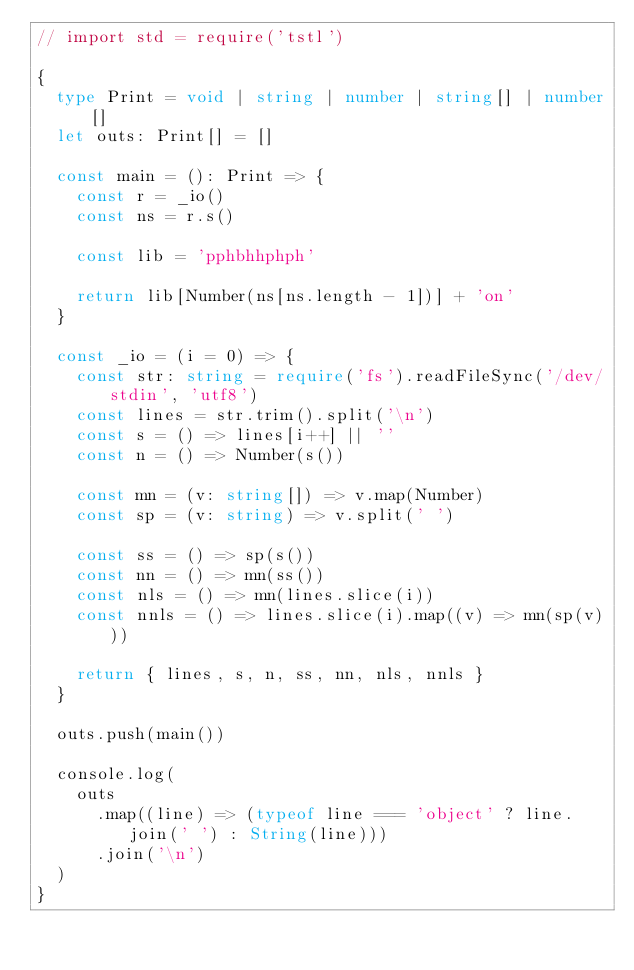Convert code to text. <code><loc_0><loc_0><loc_500><loc_500><_TypeScript_>// import std = require('tstl')

{
  type Print = void | string | number | string[] | number[]
  let outs: Print[] = []

  const main = (): Print => {
    const r = _io()
    const ns = r.s()

    const lib = 'pphbhhphph'

    return lib[Number(ns[ns.length - 1])] + 'on'
  }

  const _io = (i = 0) => {
    const str: string = require('fs').readFileSync('/dev/stdin', 'utf8')
    const lines = str.trim().split('\n')
    const s = () => lines[i++] || ''
    const n = () => Number(s())

    const mn = (v: string[]) => v.map(Number)
    const sp = (v: string) => v.split(' ')

    const ss = () => sp(s())
    const nn = () => mn(ss())
    const nls = () => mn(lines.slice(i))
    const nnls = () => lines.slice(i).map((v) => mn(sp(v)))

    return { lines, s, n, ss, nn, nls, nnls }
  }

  outs.push(main())

  console.log(
    outs
      .map((line) => (typeof line === 'object' ? line.join(' ') : String(line)))
      .join('\n')
  )
}
</code> 